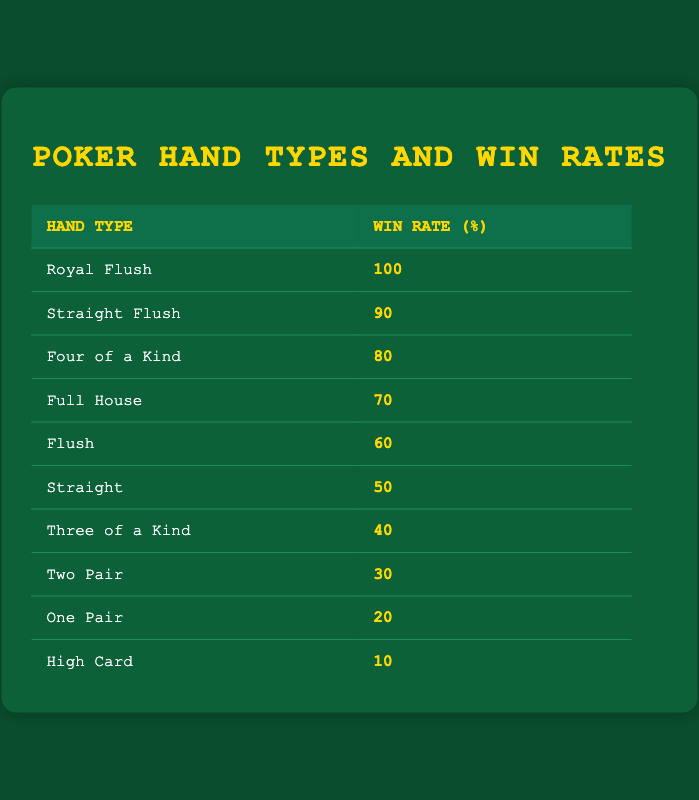What is the win rate of a Royal Flush? The win rate for a Royal Flush is listed directly in the table under the "Win Rate (%)" column next to the corresponding "Hand Type". It shows a win rate of 100.
Answer: 100 How many poker hand types have a win rate above 70%? We can see in the table that the hand types with win rates above 70% are "Royal Flush", "Straight Flush", "Four of a Kind", and "Full House". This makes a total of four hand types.
Answer: 4 What is the difference in win rates between a Full House and a Two Pair? According to the table, a Full House has a win rate of 70 and a Two Pair has a win rate of 30. Hence, the difference is calculated as 70 - 30 = 40.
Answer: 40 Is the win rate of a Flush greater than that of a Three of a Kind? Looking at the table, the win rate for a Flush is 60, while for a Three of a Kind it is 40. Since 60 is greater than 40, the statement is true.
Answer: Yes What is the average win rate of all the poker hand types listed in the table? To find the average win rate, we first sum all the win rates: 100 + 90 + 80 + 70 + 60 + 50 + 40 + 30 + 20 + 10 = 600. There are 10 hand types, so we divide 600 by 10: 600 / 10 = 60.
Answer: 60 